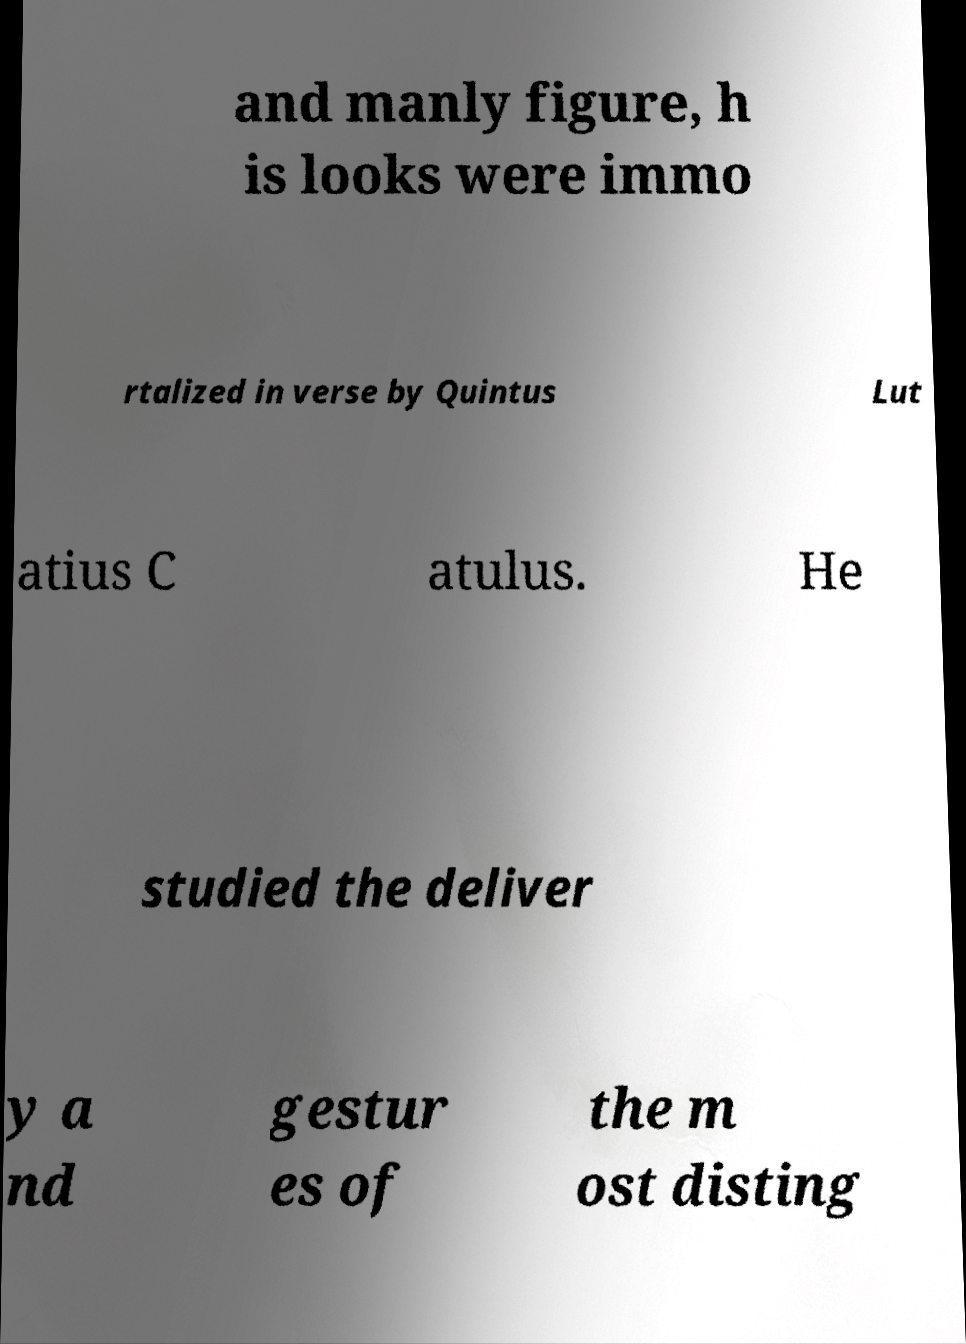Could you assist in decoding the text presented in this image and type it out clearly? and manly figure, h is looks were immo rtalized in verse by Quintus Lut atius C atulus. He studied the deliver y a nd gestur es of the m ost disting 